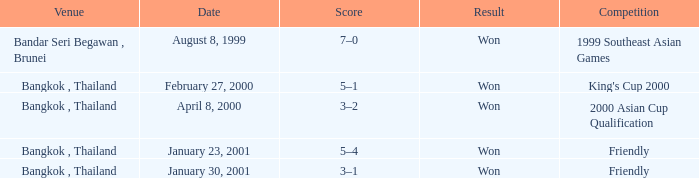What was the score from the king's cup 2000? 5–1. Parse the table in full. {'header': ['Venue', 'Date', 'Score', 'Result', 'Competition'], 'rows': [['Bandar Seri Begawan , Brunei', 'August 8, 1999', '7–0', 'Won', '1999 Southeast Asian Games'], ['Bangkok , Thailand', 'February 27, 2000', '5–1', 'Won', "King's Cup 2000"], ['Bangkok , Thailand', 'April 8, 2000', '3–2', 'Won', '2000 Asian Cup Qualification'], ['Bangkok , Thailand', 'January 23, 2001', '5–4', 'Won', 'Friendly'], ['Bangkok , Thailand', 'January 30, 2001', '3–1', 'Won', 'Friendly']]} 